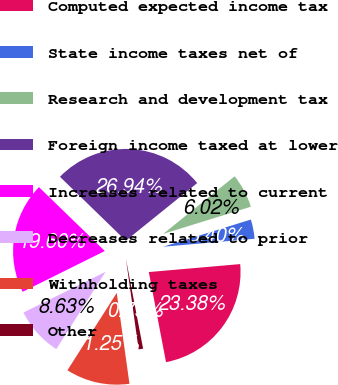Convert chart. <chart><loc_0><loc_0><loc_500><loc_500><pie_chart><fcel>Computed expected income tax<fcel>State income taxes net of<fcel>Research and development tax<fcel>Foreign income taxed at lower<fcel>Increases related to current<fcel>Decreases related to prior<fcel>Withholding taxes<fcel>Other<nl><fcel>23.38%<fcel>3.4%<fcel>6.02%<fcel>26.94%<fcel>19.6%<fcel>8.63%<fcel>11.25%<fcel>0.79%<nl></chart> 